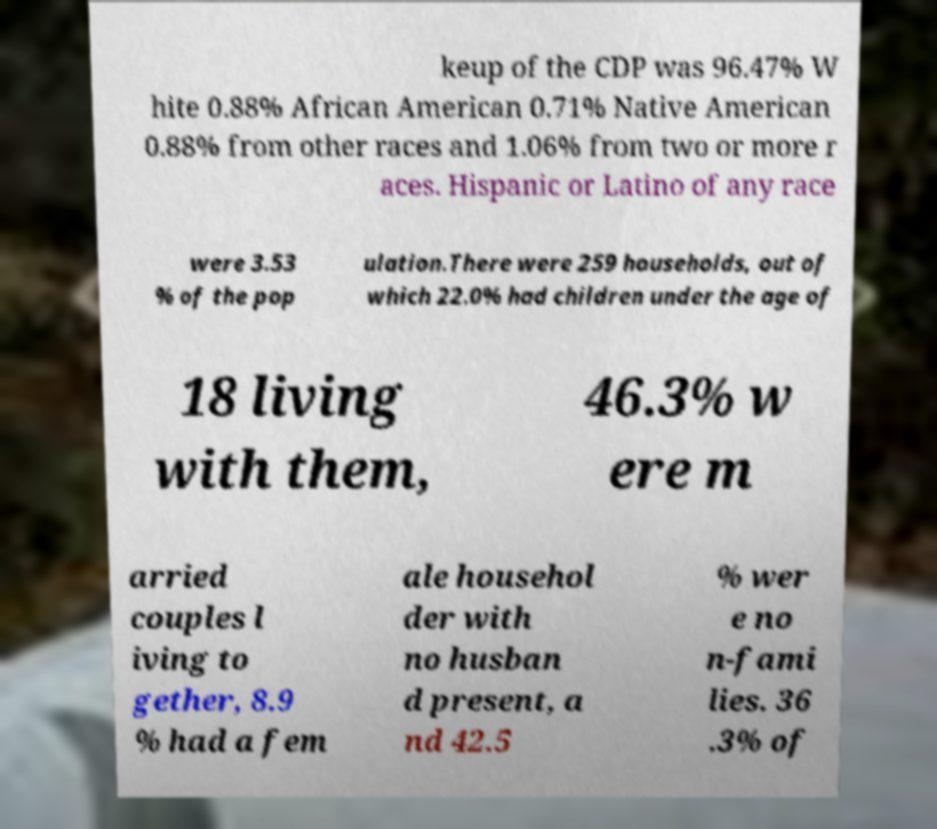Please read and relay the text visible in this image. What does it say? keup of the CDP was 96.47% W hite 0.88% African American 0.71% Native American 0.88% from other races and 1.06% from two or more r aces. Hispanic or Latino of any race were 3.53 % of the pop ulation.There were 259 households, out of which 22.0% had children under the age of 18 living with them, 46.3% w ere m arried couples l iving to gether, 8.9 % had a fem ale househol der with no husban d present, a nd 42.5 % wer e no n-fami lies. 36 .3% of 